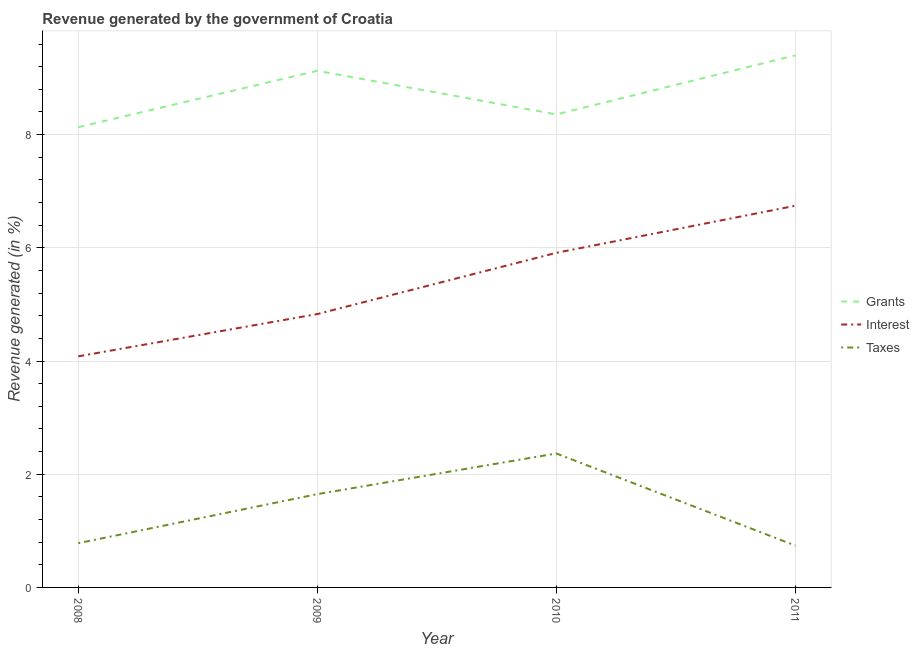Does the line corresponding to percentage of revenue generated by interest intersect with the line corresponding to percentage of revenue generated by grants?
Make the answer very short. No. What is the percentage of revenue generated by taxes in 2008?
Provide a succinct answer. 0.78. Across all years, what is the maximum percentage of revenue generated by grants?
Offer a very short reply. 9.4. Across all years, what is the minimum percentage of revenue generated by grants?
Provide a succinct answer. 8.13. In which year was the percentage of revenue generated by grants minimum?
Offer a very short reply. 2008. What is the total percentage of revenue generated by interest in the graph?
Keep it short and to the point. 21.57. What is the difference between the percentage of revenue generated by interest in 2008 and that in 2011?
Offer a terse response. -2.66. What is the difference between the percentage of revenue generated by taxes in 2008 and the percentage of revenue generated by interest in 2011?
Ensure brevity in your answer.  -5.96. What is the average percentage of revenue generated by taxes per year?
Make the answer very short. 1.38. In the year 2011, what is the difference between the percentage of revenue generated by interest and percentage of revenue generated by grants?
Keep it short and to the point. -2.66. In how many years, is the percentage of revenue generated by grants greater than 0.4 %?
Make the answer very short. 4. What is the ratio of the percentage of revenue generated by grants in 2008 to that in 2009?
Offer a terse response. 0.89. Is the percentage of revenue generated by interest in 2008 less than that in 2010?
Your answer should be very brief. Yes. Is the difference between the percentage of revenue generated by grants in 2008 and 2009 greater than the difference between the percentage of revenue generated by interest in 2008 and 2009?
Ensure brevity in your answer.  No. What is the difference between the highest and the second highest percentage of revenue generated by interest?
Keep it short and to the point. 0.83. What is the difference between the highest and the lowest percentage of revenue generated by grants?
Make the answer very short. 1.27. In how many years, is the percentage of revenue generated by interest greater than the average percentage of revenue generated by interest taken over all years?
Your answer should be compact. 2. Is the percentage of revenue generated by grants strictly greater than the percentage of revenue generated by interest over the years?
Your answer should be compact. Yes. How many lines are there?
Provide a succinct answer. 3. How many years are there in the graph?
Ensure brevity in your answer.  4. What is the difference between two consecutive major ticks on the Y-axis?
Your response must be concise. 2. Are the values on the major ticks of Y-axis written in scientific E-notation?
Give a very brief answer. No. Does the graph contain any zero values?
Provide a short and direct response. No. Does the graph contain grids?
Give a very brief answer. Yes. How are the legend labels stacked?
Offer a terse response. Vertical. What is the title of the graph?
Make the answer very short. Revenue generated by the government of Croatia. Does "Argument" appear as one of the legend labels in the graph?
Offer a very short reply. No. What is the label or title of the Y-axis?
Offer a terse response. Revenue generated (in %). What is the Revenue generated (in %) of Grants in 2008?
Ensure brevity in your answer.  8.13. What is the Revenue generated (in %) of Interest in 2008?
Provide a succinct answer. 4.08. What is the Revenue generated (in %) in Taxes in 2008?
Ensure brevity in your answer.  0.78. What is the Revenue generated (in %) of Grants in 2009?
Ensure brevity in your answer.  9.13. What is the Revenue generated (in %) in Interest in 2009?
Give a very brief answer. 4.83. What is the Revenue generated (in %) in Taxes in 2009?
Offer a terse response. 1.65. What is the Revenue generated (in %) of Grants in 2010?
Provide a succinct answer. 8.36. What is the Revenue generated (in %) in Interest in 2010?
Ensure brevity in your answer.  5.91. What is the Revenue generated (in %) in Taxes in 2010?
Make the answer very short. 2.37. What is the Revenue generated (in %) in Grants in 2011?
Keep it short and to the point. 9.4. What is the Revenue generated (in %) of Interest in 2011?
Your response must be concise. 6.74. What is the Revenue generated (in %) in Taxes in 2011?
Keep it short and to the point. 0.74. Across all years, what is the maximum Revenue generated (in %) in Grants?
Offer a very short reply. 9.4. Across all years, what is the maximum Revenue generated (in %) in Interest?
Provide a succinct answer. 6.74. Across all years, what is the maximum Revenue generated (in %) in Taxes?
Keep it short and to the point. 2.37. Across all years, what is the minimum Revenue generated (in %) in Grants?
Make the answer very short. 8.13. Across all years, what is the minimum Revenue generated (in %) of Interest?
Your answer should be very brief. 4.08. Across all years, what is the minimum Revenue generated (in %) in Taxes?
Provide a short and direct response. 0.74. What is the total Revenue generated (in %) of Grants in the graph?
Your answer should be compact. 35.02. What is the total Revenue generated (in %) of Interest in the graph?
Your answer should be very brief. 21.57. What is the total Revenue generated (in %) in Taxes in the graph?
Your answer should be compact. 5.54. What is the difference between the Revenue generated (in %) of Grants in 2008 and that in 2009?
Your answer should be very brief. -1. What is the difference between the Revenue generated (in %) of Interest in 2008 and that in 2009?
Provide a succinct answer. -0.75. What is the difference between the Revenue generated (in %) in Taxes in 2008 and that in 2009?
Make the answer very short. -0.87. What is the difference between the Revenue generated (in %) of Grants in 2008 and that in 2010?
Offer a terse response. -0.23. What is the difference between the Revenue generated (in %) in Interest in 2008 and that in 2010?
Keep it short and to the point. -1.83. What is the difference between the Revenue generated (in %) of Taxes in 2008 and that in 2010?
Provide a succinct answer. -1.59. What is the difference between the Revenue generated (in %) of Grants in 2008 and that in 2011?
Your response must be concise. -1.27. What is the difference between the Revenue generated (in %) in Interest in 2008 and that in 2011?
Provide a succinct answer. -2.66. What is the difference between the Revenue generated (in %) in Taxes in 2008 and that in 2011?
Ensure brevity in your answer.  0.04. What is the difference between the Revenue generated (in %) of Grants in 2009 and that in 2010?
Your answer should be very brief. 0.77. What is the difference between the Revenue generated (in %) of Interest in 2009 and that in 2010?
Your answer should be very brief. -1.08. What is the difference between the Revenue generated (in %) in Taxes in 2009 and that in 2010?
Keep it short and to the point. -0.72. What is the difference between the Revenue generated (in %) in Grants in 2009 and that in 2011?
Your answer should be very brief. -0.27. What is the difference between the Revenue generated (in %) of Interest in 2009 and that in 2011?
Provide a succinct answer. -1.91. What is the difference between the Revenue generated (in %) in Taxes in 2009 and that in 2011?
Ensure brevity in your answer.  0.91. What is the difference between the Revenue generated (in %) in Grants in 2010 and that in 2011?
Ensure brevity in your answer.  -1.04. What is the difference between the Revenue generated (in %) in Interest in 2010 and that in 2011?
Your answer should be very brief. -0.83. What is the difference between the Revenue generated (in %) in Taxes in 2010 and that in 2011?
Give a very brief answer. 1.63. What is the difference between the Revenue generated (in %) in Grants in 2008 and the Revenue generated (in %) in Interest in 2009?
Make the answer very short. 3.3. What is the difference between the Revenue generated (in %) in Grants in 2008 and the Revenue generated (in %) in Taxes in 2009?
Offer a terse response. 6.48. What is the difference between the Revenue generated (in %) in Interest in 2008 and the Revenue generated (in %) in Taxes in 2009?
Give a very brief answer. 2.43. What is the difference between the Revenue generated (in %) in Grants in 2008 and the Revenue generated (in %) in Interest in 2010?
Your answer should be very brief. 2.22. What is the difference between the Revenue generated (in %) of Grants in 2008 and the Revenue generated (in %) of Taxes in 2010?
Your answer should be very brief. 5.76. What is the difference between the Revenue generated (in %) in Interest in 2008 and the Revenue generated (in %) in Taxes in 2010?
Your response must be concise. 1.72. What is the difference between the Revenue generated (in %) in Grants in 2008 and the Revenue generated (in %) in Interest in 2011?
Ensure brevity in your answer.  1.39. What is the difference between the Revenue generated (in %) of Grants in 2008 and the Revenue generated (in %) of Taxes in 2011?
Offer a terse response. 7.39. What is the difference between the Revenue generated (in %) of Interest in 2008 and the Revenue generated (in %) of Taxes in 2011?
Keep it short and to the point. 3.34. What is the difference between the Revenue generated (in %) of Grants in 2009 and the Revenue generated (in %) of Interest in 2010?
Provide a short and direct response. 3.22. What is the difference between the Revenue generated (in %) of Grants in 2009 and the Revenue generated (in %) of Taxes in 2010?
Make the answer very short. 6.76. What is the difference between the Revenue generated (in %) of Interest in 2009 and the Revenue generated (in %) of Taxes in 2010?
Offer a very short reply. 2.46. What is the difference between the Revenue generated (in %) of Grants in 2009 and the Revenue generated (in %) of Interest in 2011?
Ensure brevity in your answer.  2.38. What is the difference between the Revenue generated (in %) in Grants in 2009 and the Revenue generated (in %) in Taxes in 2011?
Make the answer very short. 8.39. What is the difference between the Revenue generated (in %) of Interest in 2009 and the Revenue generated (in %) of Taxes in 2011?
Your response must be concise. 4.09. What is the difference between the Revenue generated (in %) in Grants in 2010 and the Revenue generated (in %) in Interest in 2011?
Offer a very short reply. 1.61. What is the difference between the Revenue generated (in %) in Grants in 2010 and the Revenue generated (in %) in Taxes in 2011?
Offer a terse response. 7.62. What is the difference between the Revenue generated (in %) in Interest in 2010 and the Revenue generated (in %) in Taxes in 2011?
Your answer should be very brief. 5.17. What is the average Revenue generated (in %) of Grants per year?
Provide a succinct answer. 8.75. What is the average Revenue generated (in %) in Interest per year?
Ensure brevity in your answer.  5.39. What is the average Revenue generated (in %) in Taxes per year?
Offer a terse response. 1.38. In the year 2008, what is the difference between the Revenue generated (in %) in Grants and Revenue generated (in %) in Interest?
Give a very brief answer. 4.05. In the year 2008, what is the difference between the Revenue generated (in %) in Grants and Revenue generated (in %) in Taxes?
Offer a very short reply. 7.35. In the year 2008, what is the difference between the Revenue generated (in %) in Interest and Revenue generated (in %) in Taxes?
Your answer should be very brief. 3.3. In the year 2009, what is the difference between the Revenue generated (in %) in Grants and Revenue generated (in %) in Interest?
Make the answer very short. 4.3. In the year 2009, what is the difference between the Revenue generated (in %) in Grants and Revenue generated (in %) in Taxes?
Offer a terse response. 7.48. In the year 2009, what is the difference between the Revenue generated (in %) in Interest and Revenue generated (in %) in Taxes?
Provide a short and direct response. 3.18. In the year 2010, what is the difference between the Revenue generated (in %) in Grants and Revenue generated (in %) in Interest?
Give a very brief answer. 2.45. In the year 2010, what is the difference between the Revenue generated (in %) in Grants and Revenue generated (in %) in Taxes?
Make the answer very short. 5.99. In the year 2010, what is the difference between the Revenue generated (in %) of Interest and Revenue generated (in %) of Taxes?
Provide a succinct answer. 3.54. In the year 2011, what is the difference between the Revenue generated (in %) in Grants and Revenue generated (in %) in Interest?
Your response must be concise. 2.66. In the year 2011, what is the difference between the Revenue generated (in %) in Grants and Revenue generated (in %) in Taxes?
Ensure brevity in your answer.  8.66. In the year 2011, what is the difference between the Revenue generated (in %) in Interest and Revenue generated (in %) in Taxes?
Your response must be concise. 6. What is the ratio of the Revenue generated (in %) in Grants in 2008 to that in 2009?
Your response must be concise. 0.89. What is the ratio of the Revenue generated (in %) in Interest in 2008 to that in 2009?
Your answer should be compact. 0.85. What is the ratio of the Revenue generated (in %) in Taxes in 2008 to that in 2009?
Your answer should be very brief. 0.47. What is the ratio of the Revenue generated (in %) of Grants in 2008 to that in 2010?
Offer a very short reply. 0.97. What is the ratio of the Revenue generated (in %) in Interest in 2008 to that in 2010?
Your answer should be compact. 0.69. What is the ratio of the Revenue generated (in %) in Taxes in 2008 to that in 2010?
Make the answer very short. 0.33. What is the ratio of the Revenue generated (in %) of Grants in 2008 to that in 2011?
Give a very brief answer. 0.86. What is the ratio of the Revenue generated (in %) of Interest in 2008 to that in 2011?
Offer a very short reply. 0.61. What is the ratio of the Revenue generated (in %) of Taxes in 2008 to that in 2011?
Provide a short and direct response. 1.06. What is the ratio of the Revenue generated (in %) of Grants in 2009 to that in 2010?
Your response must be concise. 1.09. What is the ratio of the Revenue generated (in %) of Interest in 2009 to that in 2010?
Ensure brevity in your answer.  0.82. What is the ratio of the Revenue generated (in %) of Taxes in 2009 to that in 2010?
Your response must be concise. 0.7. What is the ratio of the Revenue generated (in %) of Grants in 2009 to that in 2011?
Offer a terse response. 0.97. What is the ratio of the Revenue generated (in %) in Interest in 2009 to that in 2011?
Keep it short and to the point. 0.72. What is the ratio of the Revenue generated (in %) in Taxes in 2009 to that in 2011?
Provide a succinct answer. 2.23. What is the ratio of the Revenue generated (in %) of Grants in 2010 to that in 2011?
Offer a terse response. 0.89. What is the ratio of the Revenue generated (in %) of Interest in 2010 to that in 2011?
Your answer should be very brief. 0.88. What is the ratio of the Revenue generated (in %) of Taxes in 2010 to that in 2011?
Offer a terse response. 3.2. What is the difference between the highest and the second highest Revenue generated (in %) in Grants?
Provide a succinct answer. 0.27. What is the difference between the highest and the second highest Revenue generated (in %) in Interest?
Ensure brevity in your answer.  0.83. What is the difference between the highest and the second highest Revenue generated (in %) in Taxes?
Keep it short and to the point. 0.72. What is the difference between the highest and the lowest Revenue generated (in %) of Grants?
Make the answer very short. 1.27. What is the difference between the highest and the lowest Revenue generated (in %) in Interest?
Provide a short and direct response. 2.66. What is the difference between the highest and the lowest Revenue generated (in %) in Taxes?
Your answer should be compact. 1.63. 